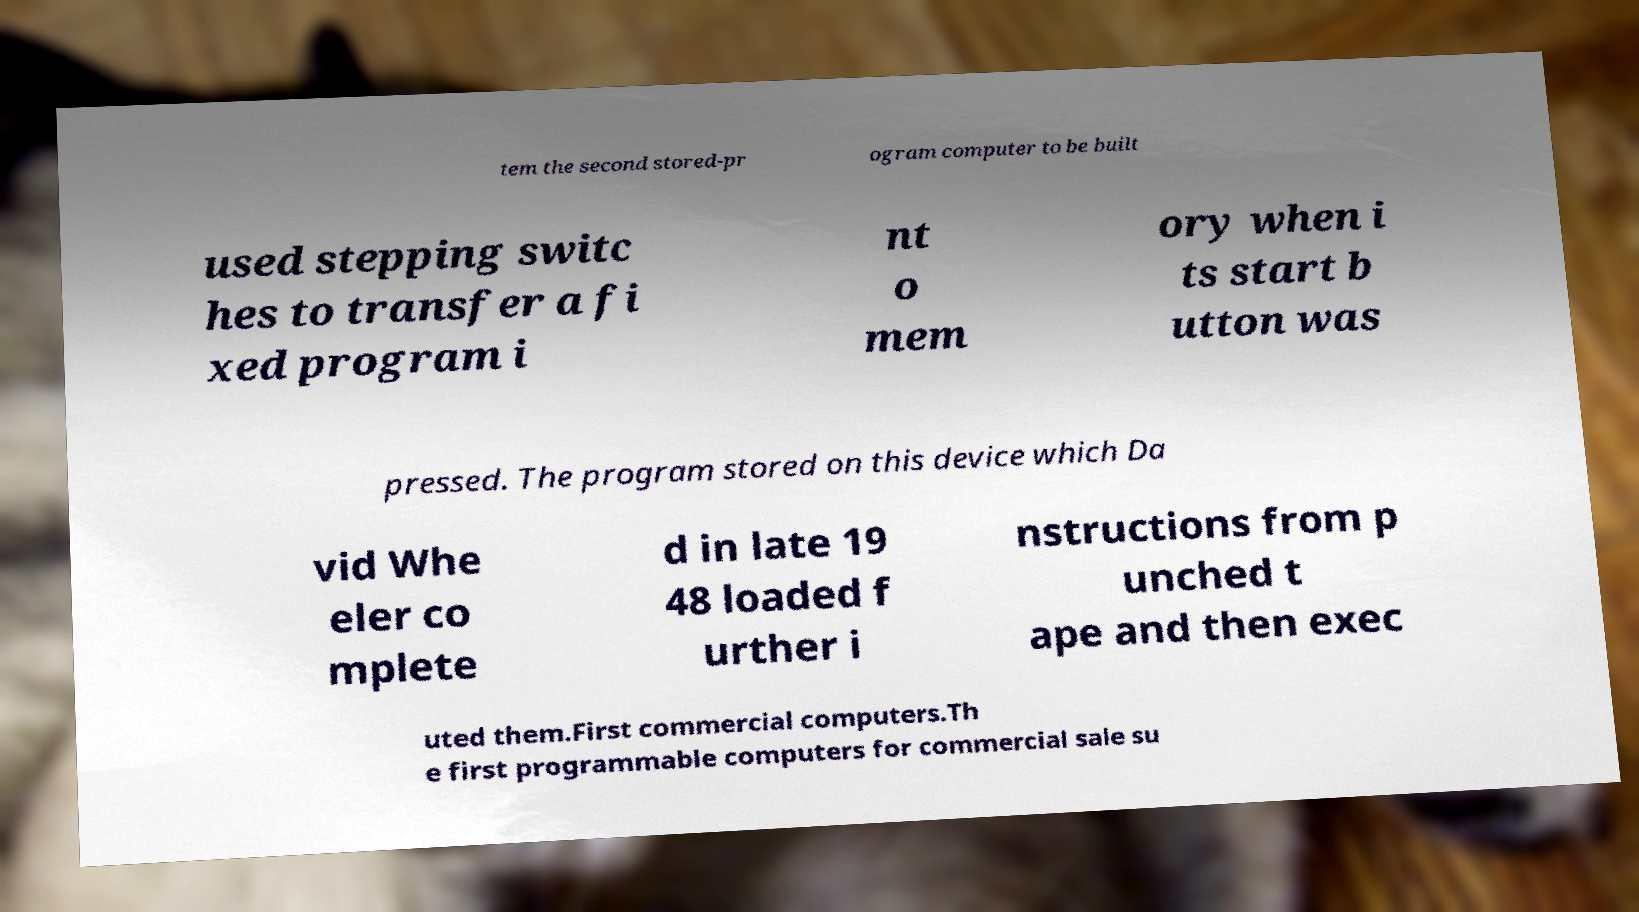Could you extract and type out the text from this image? tem the second stored-pr ogram computer to be built used stepping switc hes to transfer a fi xed program i nt o mem ory when i ts start b utton was pressed. The program stored on this device which Da vid Whe eler co mplete d in late 19 48 loaded f urther i nstructions from p unched t ape and then exec uted them.First commercial computers.Th e first programmable computers for commercial sale su 